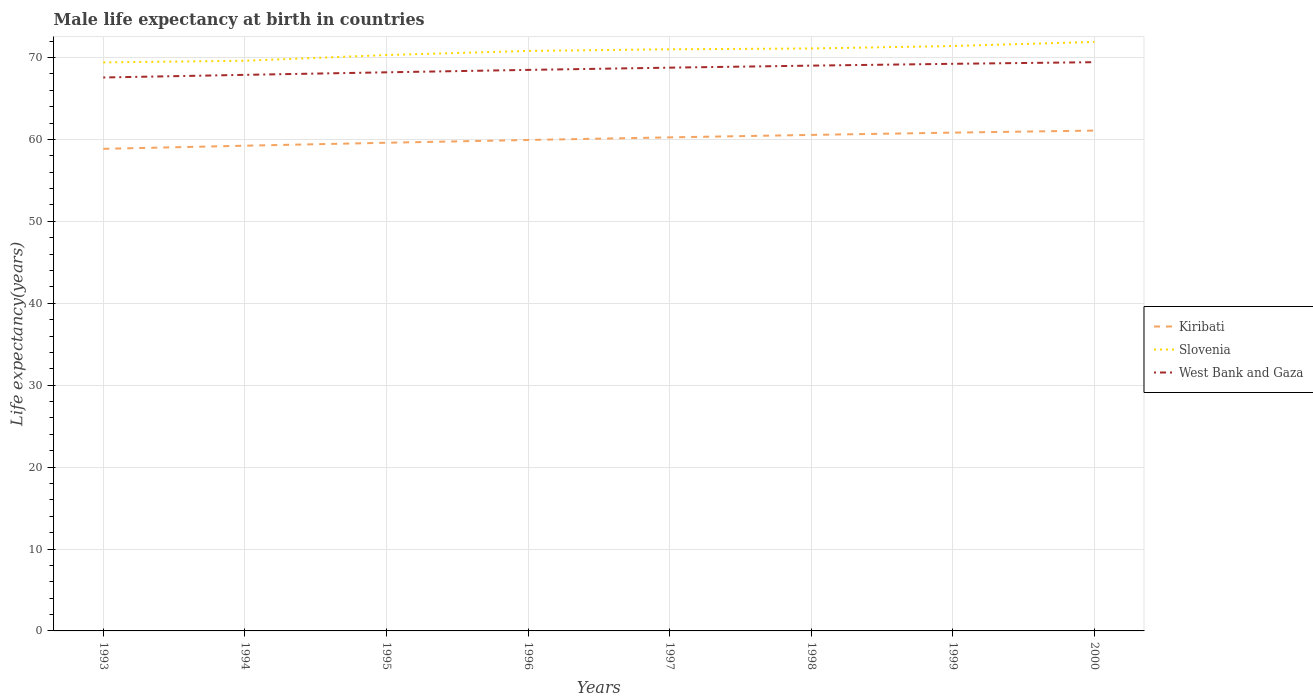Across all years, what is the maximum male life expectancy at birth in Kiribati?
Your answer should be compact. 58.85. What is the total male life expectancy at birth in West Bank and Gaza in the graph?
Ensure brevity in your answer.  -0.94. How many years are there in the graph?
Your answer should be compact. 8. What is the difference between two consecutive major ticks on the Y-axis?
Your answer should be compact. 10. Are the values on the major ticks of Y-axis written in scientific E-notation?
Provide a succinct answer. No. Does the graph contain grids?
Provide a short and direct response. Yes. What is the title of the graph?
Offer a very short reply. Male life expectancy at birth in countries. What is the label or title of the Y-axis?
Provide a short and direct response. Life expectancy(years). What is the Life expectancy(years) in Kiribati in 1993?
Ensure brevity in your answer.  58.85. What is the Life expectancy(years) of Slovenia in 1993?
Your answer should be very brief. 69.4. What is the Life expectancy(years) of West Bank and Gaza in 1993?
Offer a terse response. 67.56. What is the Life expectancy(years) in Kiribati in 1994?
Provide a short and direct response. 59.23. What is the Life expectancy(years) of Slovenia in 1994?
Your response must be concise. 69.6. What is the Life expectancy(years) in West Bank and Gaza in 1994?
Keep it short and to the point. 67.88. What is the Life expectancy(years) in Kiribati in 1995?
Your answer should be very brief. 59.59. What is the Life expectancy(years) in Slovenia in 1995?
Provide a short and direct response. 70.3. What is the Life expectancy(years) of West Bank and Gaza in 1995?
Your answer should be very brief. 68.19. What is the Life expectancy(years) in Kiribati in 1996?
Offer a terse response. 59.93. What is the Life expectancy(years) of Slovenia in 1996?
Offer a very short reply. 70.8. What is the Life expectancy(years) in West Bank and Gaza in 1996?
Offer a very short reply. 68.48. What is the Life expectancy(years) in Kiribati in 1997?
Make the answer very short. 60.25. What is the Life expectancy(years) in Slovenia in 1997?
Offer a very short reply. 71. What is the Life expectancy(years) in West Bank and Gaza in 1997?
Offer a terse response. 68.76. What is the Life expectancy(years) in Kiribati in 1998?
Provide a succinct answer. 60.55. What is the Life expectancy(years) in Slovenia in 1998?
Ensure brevity in your answer.  71.1. What is the Life expectancy(years) in West Bank and Gaza in 1998?
Your answer should be compact. 69.01. What is the Life expectancy(years) in Kiribati in 1999?
Provide a short and direct response. 60.83. What is the Life expectancy(years) in Slovenia in 1999?
Your answer should be compact. 71.4. What is the Life expectancy(years) of West Bank and Gaza in 1999?
Provide a short and direct response. 69.23. What is the Life expectancy(years) of Kiribati in 2000?
Keep it short and to the point. 61.08. What is the Life expectancy(years) in Slovenia in 2000?
Your response must be concise. 71.9. What is the Life expectancy(years) in West Bank and Gaza in 2000?
Provide a succinct answer. 69.43. Across all years, what is the maximum Life expectancy(years) of Kiribati?
Provide a short and direct response. 61.08. Across all years, what is the maximum Life expectancy(years) in Slovenia?
Give a very brief answer. 71.9. Across all years, what is the maximum Life expectancy(years) of West Bank and Gaza?
Your answer should be compact. 69.43. Across all years, what is the minimum Life expectancy(years) of Kiribati?
Offer a very short reply. 58.85. Across all years, what is the minimum Life expectancy(years) of Slovenia?
Ensure brevity in your answer.  69.4. Across all years, what is the minimum Life expectancy(years) in West Bank and Gaza?
Keep it short and to the point. 67.56. What is the total Life expectancy(years) in Kiribati in the graph?
Ensure brevity in your answer.  480.31. What is the total Life expectancy(years) of Slovenia in the graph?
Make the answer very short. 565.5. What is the total Life expectancy(years) of West Bank and Gaza in the graph?
Provide a short and direct response. 548.53. What is the difference between the Life expectancy(years) in Kiribati in 1993 and that in 1994?
Ensure brevity in your answer.  -0.38. What is the difference between the Life expectancy(years) in West Bank and Gaza in 1993 and that in 1994?
Make the answer very short. -0.32. What is the difference between the Life expectancy(years) in Kiribati in 1993 and that in 1995?
Offer a very short reply. -0.74. What is the difference between the Life expectancy(years) in Slovenia in 1993 and that in 1995?
Your answer should be compact. -0.9. What is the difference between the Life expectancy(years) in West Bank and Gaza in 1993 and that in 1995?
Offer a very short reply. -0.63. What is the difference between the Life expectancy(years) of Kiribati in 1993 and that in 1996?
Provide a short and direct response. -1.08. What is the difference between the Life expectancy(years) of West Bank and Gaza in 1993 and that in 1996?
Offer a terse response. -0.93. What is the difference between the Life expectancy(years) of Kiribati in 1993 and that in 1997?
Provide a succinct answer. -1.4. What is the difference between the Life expectancy(years) in West Bank and Gaza in 1993 and that in 1997?
Keep it short and to the point. -1.2. What is the difference between the Life expectancy(years) in Kiribati in 1993 and that in 1998?
Your response must be concise. -1.7. What is the difference between the Life expectancy(years) in Slovenia in 1993 and that in 1998?
Offer a terse response. -1.7. What is the difference between the Life expectancy(years) in West Bank and Gaza in 1993 and that in 1998?
Keep it short and to the point. -1.45. What is the difference between the Life expectancy(years) in Kiribati in 1993 and that in 1999?
Provide a succinct answer. -1.98. What is the difference between the Life expectancy(years) in West Bank and Gaza in 1993 and that in 1999?
Provide a succinct answer. -1.67. What is the difference between the Life expectancy(years) of Kiribati in 1993 and that in 2000?
Provide a succinct answer. -2.23. What is the difference between the Life expectancy(years) in Slovenia in 1993 and that in 2000?
Offer a terse response. -2.5. What is the difference between the Life expectancy(years) of West Bank and Gaza in 1993 and that in 2000?
Offer a very short reply. -1.87. What is the difference between the Life expectancy(years) of Kiribati in 1994 and that in 1995?
Your response must be concise. -0.36. What is the difference between the Life expectancy(years) of Slovenia in 1994 and that in 1995?
Your answer should be very brief. -0.7. What is the difference between the Life expectancy(years) in West Bank and Gaza in 1994 and that in 1995?
Your answer should be very brief. -0.31. What is the difference between the Life expectancy(years) in Kiribati in 1994 and that in 1996?
Provide a succinct answer. -0.7. What is the difference between the Life expectancy(years) in West Bank and Gaza in 1994 and that in 1996?
Keep it short and to the point. -0.6. What is the difference between the Life expectancy(years) in Kiribati in 1994 and that in 1997?
Offer a terse response. -1.02. What is the difference between the Life expectancy(years) of West Bank and Gaza in 1994 and that in 1997?
Give a very brief answer. -0.88. What is the difference between the Life expectancy(years) of Kiribati in 1994 and that in 1998?
Provide a short and direct response. -1.32. What is the difference between the Life expectancy(years) in Slovenia in 1994 and that in 1998?
Make the answer very short. -1.5. What is the difference between the Life expectancy(years) in West Bank and Gaza in 1994 and that in 1998?
Give a very brief answer. -1.13. What is the difference between the Life expectancy(years) in Kiribati in 1994 and that in 1999?
Keep it short and to the point. -1.6. What is the difference between the Life expectancy(years) in Slovenia in 1994 and that in 1999?
Provide a succinct answer. -1.8. What is the difference between the Life expectancy(years) in West Bank and Gaza in 1994 and that in 1999?
Provide a short and direct response. -1.35. What is the difference between the Life expectancy(years) in Kiribati in 1994 and that in 2000?
Your answer should be very brief. -1.85. What is the difference between the Life expectancy(years) of West Bank and Gaza in 1994 and that in 2000?
Your answer should be very brief. -1.55. What is the difference between the Life expectancy(years) in Kiribati in 1995 and that in 1996?
Provide a short and direct response. -0.34. What is the difference between the Life expectancy(years) in West Bank and Gaza in 1995 and that in 1996?
Offer a very short reply. -0.29. What is the difference between the Life expectancy(years) of Kiribati in 1995 and that in 1997?
Your response must be concise. -0.66. What is the difference between the Life expectancy(years) in Slovenia in 1995 and that in 1997?
Your answer should be compact. -0.7. What is the difference between the Life expectancy(years) in West Bank and Gaza in 1995 and that in 1997?
Keep it short and to the point. -0.57. What is the difference between the Life expectancy(years) in Kiribati in 1995 and that in 1998?
Make the answer very short. -0.96. What is the difference between the Life expectancy(years) in Slovenia in 1995 and that in 1998?
Your answer should be very brief. -0.8. What is the difference between the Life expectancy(years) in West Bank and Gaza in 1995 and that in 1998?
Your response must be concise. -0.82. What is the difference between the Life expectancy(years) in Kiribati in 1995 and that in 1999?
Give a very brief answer. -1.24. What is the difference between the Life expectancy(years) in Slovenia in 1995 and that in 1999?
Make the answer very short. -1.1. What is the difference between the Life expectancy(years) of West Bank and Gaza in 1995 and that in 1999?
Provide a short and direct response. -1.04. What is the difference between the Life expectancy(years) in Kiribati in 1995 and that in 2000?
Ensure brevity in your answer.  -1.49. What is the difference between the Life expectancy(years) in West Bank and Gaza in 1995 and that in 2000?
Ensure brevity in your answer.  -1.24. What is the difference between the Life expectancy(years) of Kiribati in 1996 and that in 1997?
Offer a terse response. -0.32. What is the difference between the Life expectancy(years) of West Bank and Gaza in 1996 and that in 1997?
Ensure brevity in your answer.  -0.27. What is the difference between the Life expectancy(years) in Kiribati in 1996 and that in 1998?
Keep it short and to the point. -0.62. What is the difference between the Life expectancy(years) in West Bank and Gaza in 1996 and that in 1998?
Provide a short and direct response. -0.52. What is the difference between the Life expectancy(years) in Kiribati in 1996 and that in 1999?
Ensure brevity in your answer.  -0.9. What is the difference between the Life expectancy(years) of Slovenia in 1996 and that in 1999?
Your response must be concise. -0.6. What is the difference between the Life expectancy(years) of West Bank and Gaza in 1996 and that in 1999?
Provide a succinct answer. -0.74. What is the difference between the Life expectancy(years) in Kiribati in 1996 and that in 2000?
Make the answer very short. -1.15. What is the difference between the Life expectancy(years) in West Bank and Gaza in 1996 and that in 2000?
Keep it short and to the point. -0.94. What is the difference between the Life expectancy(years) in Kiribati in 1997 and that in 1998?
Make the answer very short. -0.3. What is the difference between the Life expectancy(years) of Slovenia in 1997 and that in 1998?
Give a very brief answer. -0.1. What is the difference between the Life expectancy(years) of West Bank and Gaza in 1997 and that in 1998?
Your answer should be compact. -0.25. What is the difference between the Life expectancy(years) of Kiribati in 1997 and that in 1999?
Keep it short and to the point. -0.58. What is the difference between the Life expectancy(years) in West Bank and Gaza in 1997 and that in 1999?
Your answer should be very brief. -0.47. What is the difference between the Life expectancy(years) in Kiribati in 1997 and that in 2000?
Provide a short and direct response. -0.83. What is the difference between the Life expectancy(years) in Slovenia in 1997 and that in 2000?
Keep it short and to the point. -0.9. What is the difference between the Life expectancy(years) in West Bank and Gaza in 1997 and that in 2000?
Offer a very short reply. -0.67. What is the difference between the Life expectancy(years) of Kiribati in 1998 and that in 1999?
Give a very brief answer. -0.28. What is the difference between the Life expectancy(years) in Slovenia in 1998 and that in 1999?
Your response must be concise. -0.3. What is the difference between the Life expectancy(years) in West Bank and Gaza in 1998 and that in 1999?
Your response must be concise. -0.22. What is the difference between the Life expectancy(years) in Kiribati in 1998 and that in 2000?
Make the answer very short. -0.53. What is the difference between the Life expectancy(years) of West Bank and Gaza in 1998 and that in 2000?
Your answer should be very brief. -0.42. What is the difference between the Life expectancy(years) of Kiribati in 1999 and that in 2000?
Provide a short and direct response. -0.25. What is the difference between the Life expectancy(years) in West Bank and Gaza in 1999 and that in 2000?
Your answer should be very brief. -0.2. What is the difference between the Life expectancy(years) in Kiribati in 1993 and the Life expectancy(years) in Slovenia in 1994?
Your response must be concise. -10.75. What is the difference between the Life expectancy(years) of Kiribati in 1993 and the Life expectancy(years) of West Bank and Gaza in 1994?
Offer a very short reply. -9.03. What is the difference between the Life expectancy(years) of Slovenia in 1993 and the Life expectancy(years) of West Bank and Gaza in 1994?
Provide a succinct answer. 1.52. What is the difference between the Life expectancy(years) of Kiribati in 1993 and the Life expectancy(years) of Slovenia in 1995?
Your response must be concise. -11.45. What is the difference between the Life expectancy(years) of Kiribati in 1993 and the Life expectancy(years) of West Bank and Gaza in 1995?
Ensure brevity in your answer.  -9.34. What is the difference between the Life expectancy(years) of Slovenia in 1993 and the Life expectancy(years) of West Bank and Gaza in 1995?
Make the answer very short. 1.21. What is the difference between the Life expectancy(years) of Kiribati in 1993 and the Life expectancy(years) of Slovenia in 1996?
Offer a terse response. -11.95. What is the difference between the Life expectancy(years) in Kiribati in 1993 and the Life expectancy(years) in West Bank and Gaza in 1996?
Keep it short and to the point. -9.64. What is the difference between the Life expectancy(years) of Slovenia in 1993 and the Life expectancy(years) of West Bank and Gaza in 1996?
Your answer should be compact. 0.92. What is the difference between the Life expectancy(years) in Kiribati in 1993 and the Life expectancy(years) in Slovenia in 1997?
Your answer should be compact. -12.15. What is the difference between the Life expectancy(years) of Kiribati in 1993 and the Life expectancy(years) of West Bank and Gaza in 1997?
Provide a short and direct response. -9.91. What is the difference between the Life expectancy(years) in Slovenia in 1993 and the Life expectancy(years) in West Bank and Gaza in 1997?
Your response must be concise. 0.64. What is the difference between the Life expectancy(years) of Kiribati in 1993 and the Life expectancy(years) of Slovenia in 1998?
Make the answer very short. -12.25. What is the difference between the Life expectancy(years) of Kiribati in 1993 and the Life expectancy(years) of West Bank and Gaza in 1998?
Your answer should be very brief. -10.16. What is the difference between the Life expectancy(years) of Slovenia in 1993 and the Life expectancy(years) of West Bank and Gaza in 1998?
Provide a succinct answer. 0.39. What is the difference between the Life expectancy(years) in Kiribati in 1993 and the Life expectancy(years) in Slovenia in 1999?
Your answer should be very brief. -12.55. What is the difference between the Life expectancy(years) in Kiribati in 1993 and the Life expectancy(years) in West Bank and Gaza in 1999?
Provide a short and direct response. -10.38. What is the difference between the Life expectancy(years) of Slovenia in 1993 and the Life expectancy(years) of West Bank and Gaza in 1999?
Your answer should be very brief. 0.17. What is the difference between the Life expectancy(years) in Kiribati in 1993 and the Life expectancy(years) in Slovenia in 2000?
Offer a terse response. -13.05. What is the difference between the Life expectancy(years) in Kiribati in 1993 and the Life expectancy(years) in West Bank and Gaza in 2000?
Your answer should be very brief. -10.58. What is the difference between the Life expectancy(years) in Slovenia in 1993 and the Life expectancy(years) in West Bank and Gaza in 2000?
Your answer should be very brief. -0.03. What is the difference between the Life expectancy(years) of Kiribati in 1994 and the Life expectancy(years) of Slovenia in 1995?
Offer a terse response. -11.07. What is the difference between the Life expectancy(years) in Kiribati in 1994 and the Life expectancy(years) in West Bank and Gaza in 1995?
Provide a short and direct response. -8.96. What is the difference between the Life expectancy(years) of Slovenia in 1994 and the Life expectancy(years) of West Bank and Gaza in 1995?
Ensure brevity in your answer.  1.41. What is the difference between the Life expectancy(years) in Kiribati in 1994 and the Life expectancy(years) in Slovenia in 1996?
Keep it short and to the point. -11.57. What is the difference between the Life expectancy(years) in Kiribati in 1994 and the Life expectancy(years) in West Bank and Gaza in 1996?
Offer a terse response. -9.25. What is the difference between the Life expectancy(years) of Slovenia in 1994 and the Life expectancy(years) of West Bank and Gaza in 1996?
Your response must be concise. 1.11. What is the difference between the Life expectancy(years) in Kiribati in 1994 and the Life expectancy(years) in Slovenia in 1997?
Provide a short and direct response. -11.77. What is the difference between the Life expectancy(years) of Kiribati in 1994 and the Life expectancy(years) of West Bank and Gaza in 1997?
Make the answer very short. -9.53. What is the difference between the Life expectancy(years) in Slovenia in 1994 and the Life expectancy(years) in West Bank and Gaza in 1997?
Your answer should be compact. 0.84. What is the difference between the Life expectancy(years) of Kiribati in 1994 and the Life expectancy(years) of Slovenia in 1998?
Provide a succinct answer. -11.87. What is the difference between the Life expectancy(years) in Kiribati in 1994 and the Life expectancy(years) in West Bank and Gaza in 1998?
Your response must be concise. -9.78. What is the difference between the Life expectancy(years) in Slovenia in 1994 and the Life expectancy(years) in West Bank and Gaza in 1998?
Keep it short and to the point. 0.59. What is the difference between the Life expectancy(years) in Kiribati in 1994 and the Life expectancy(years) in Slovenia in 1999?
Make the answer very short. -12.17. What is the difference between the Life expectancy(years) of Kiribati in 1994 and the Life expectancy(years) of West Bank and Gaza in 1999?
Offer a terse response. -10. What is the difference between the Life expectancy(years) in Slovenia in 1994 and the Life expectancy(years) in West Bank and Gaza in 1999?
Provide a short and direct response. 0.37. What is the difference between the Life expectancy(years) of Kiribati in 1994 and the Life expectancy(years) of Slovenia in 2000?
Provide a short and direct response. -12.67. What is the difference between the Life expectancy(years) in Kiribati in 1994 and the Life expectancy(years) in West Bank and Gaza in 2000?
Your answer should be compact. -10.2. What is the difference between the Life expectancy(years) in Slovenia in 1994 and the Life expectancy(years) in West Bank and Gaza in 2000?
Keep it short and to the point. 0.17. What is the difference between the Life expectancy(years) in Kiribati in 1995 and the Life expectancy(years) in Slovenia in 1996?
Ensure brevity in your answer.  -11.21. What is the difference between the Life expectancy(years) of Kiribati in 1995 and the Life expectancy(years) of West Bank and Gaza in 1996?
Your answer should be very brief. -8.89. What is the difference between the Life expectancy(years) in Slovenia in 1995 and the Life expectancy(years) in West Bank and Gaza in 1996?
Make the answer very short. 1.81. What is the difference between the Life expectancy(years) of Kiribati in 1995 and the Life expectancy(years) of Slovenia in 1997?
Ensure brevity in your answer.  -11.41. What is the difference between the Life expectancy(years) in Kiribati in 1995 and the Life expectancy(years) in West Bank and Gaza in 1997?
Give a very brief answer. -9.17. What is the difference between the Life expectancy(years) in Slovenia in 1995 and the Life expectancy(years) in West Bank and Gaza in 1997?
Offer a very short reply. 1.54. What is the difference between the Life expectancy(years) in Kiribati in 1995 and the Life expectancy(years) in Slovenia in 1998?
Make the answer very short. -11.51. What is the difference between the Life expectancy(years) in Kiribati in 1995 and the Life expectancy(years) in West Bank and Gaza in 1998?
Offer a very short reply. -9.41. What is the difference between the Life expectancy(years) in Slovenia in 1995 and the Life expectancy(years) in West Bank and Gaza in 1998?
Give a very brief answer. 1.29. What is the difference between the Life expectancy(years) in Kiribati in 1995 and the Life expectancy(years) in Slovenia in 1999?
Provide a succinct answer. -11.81. What is the difference between the Life expectancy(years) in Kiribati in 1995 and the Life expectancy(years) in West Bank and Gaza in 1999?
Give a very brief answer. -9.64. What is the difference between the Life expectancy(years) in Slovenia in 1995 and the Life expectancy(years) in West Bank and Gaza in 1999?
Your answer should be compact. 1.07. What is the difference between the Life expectancy(years) in Kiribati in 1995 and the Life expectancy(years) in Slovenia in 2000?
Your response must be concise. -12.31. What is the difference between the Life expectancy(years) of Kiribati in 1995 and the Life expectancy(years) of West Bank and Gaza in 2000?
Provide a short and direct response. -9.83. What is the difference between the Life expectancy(years) in Slovenia in 1995 and the Life expectancy(years) in West Bank and Gaza in 2000?
Your response must be concise. 0.87. What is the difference between the Life expectancy(years) in Kiribati in 1996 and the Life expectancy(years) in Slovenia in 1997?
Offer a terse response. -11.07. What is the difference between the Life expectancy(years) of Kiribati in 1996 and the Life expectancy(years) of West Bank and Gaza in 1997?
Keep it short and to the point. -8.83. What is the difference between the Life expectancy(years) of Slovenia in 1996 and the Life expectancy(years) of West Bank and Gaza in 1997?
Offer a very short reply. 2.04. What is the difference between the Life expectancy(years) of Kiribati in 1996 and the Life expectancy(years) of Slovenia in 1998?
Provide a short and direct response. -11.17. What is the difference between the Life expectancy(years) of Kiribati in 1996 and the Life expectancy(years) of West Bank and Gaza in 1998?
Your answer should be compact. -9.08. What is the difference between the Life expectancy(years) of Slovenia in 1996 and the Life expectancy(years) of West Bank and Gaza in 1998?
Your response must be concise. 1.79. What is the difference between the Life expectancy(years) of Kiribati in 1996 and the Life expectancy(years) of Slovenia in 1999?
Keep it short and to the point. -11.47. What is the difference between the Life expectancy(years) in Kiribati in 1996 and the Life expectancy(years) in West Bank and Gaza in 1999?
Your answer should be very brief. -9.3. What is the difference between the Life expectancy(years) of Slovenia in 1996 and the Life expectancy(years) of West Bank and Gaza in 1999?
Give a very brief answer. 1.57. What is the difference between the Life expectancy(years) in Kiribati in 1996 and the Life expectancy(years) in Slovenia in 2000?
Offer a terse response. -11.97. What is the difference between the Life expectancy(years) in Kiribati in 1996 and the Life expectancy(years) in West Bank and Gaza in 2000?
Your response must be concise. -9.5. What is the difference between the Life expectancy(years) in Slovenia in 1996 and the Life expectancy(years) in West Bank and Gaza in 2000?
Make the answer very short. 1.37. What is the difference between the Life expectancy(years) in Kiribati in 1997 and the Life expectancy(years) in Slovenia in 1998?
Provide a short and direct response. -10.85. What is the difference between the Life expectancy(years) of Kiribati in 1997 and the Life expectancy(years) of West Bank and Gaza in 1998?
Provide a short and direct response. -8.76. What is the difference between the Life expectancy(years) of Slovenia in 1997 and the Life expectancy(years) of West Bank and Gaza in 1998?
Provide a succinct answer. 1.99. What is the difference between the Life expectancy(years) of Kiribati in 1997 and the Life expectancy(years) of Slovenia in 1999?
Keep it short and to the point. -11.15. What is the difference between the Life expectancy(years) of Kiribati in 1997 and the Life expectancy(years) of West Bank and Gaza in 1999?
Offer a very short reply. -8.98. What is the difference between the Life expectancy(years) in Slovenia in 1997 and the Life expectancy(years) in West Bank and Gaza in 1999?
Provide a short and direct response. 1.77. What is the difference between the Life expectancy(years) of Kiribati in 1997 and the Life expectancy(years) of Slovenia in 2000?
Your answer should be compact. -11.65. What is the difference between the Life expectancy(years) in Kiribati in 1997 and the Life expectancy(years) in West Bank and Gaza in 2000?
Keep it short and to the point. -9.18. What is the difference between the Life expectancy(years) of Slovenia in 1997 and the Life expectancy(years) of West Bank and Gaza in 2000?
Your response must be concise. 1.57. What is the difference between the Life expectancy(years) in Kiribati in 1998 and the Life expectancy(years) in Slovenia in 1999?
Your response must be concise. -10.85. What is the difference between the Life expectancy(years) of Kiribati in 1998 and the Life expectancy(years) of West Bank and Gaza in 1999?
Offer a very short reply. -8.68. What is the difference between the Life expectancy(years) in Slovenia in 1998 and the Life expectancy(years) in West Bank and Gaza in 1999?
Your response must be concise. 1.87. What is the difference between the Life expectancy(years) of Kiribati in 1998 and the Life expectancy(years) of Slovenia in 2000?
Ensure brevity in your answer.  -11.35. What is the difference between the Life expectancy(years) in Kiribati in 1998 and the Life expectancy(years) in West Bank and Gaza in 2000?
Keep it short and to the point. -8.88. What is the difference between the Life expectancy(years) of Slovenia in 1998 and the Life expectancy(years) of West Bank and Gaza in 2000?
Your answer should be compact. 1.67. What is the difference between the Life expectancy(years) of Kiribati in 1999 and the Life expectancy(years) of Slovenia in 2000?
Make the answer very short. -11.07. What is the difference between the Life expectancy(years) in Kiribati in 1999 and the Life expectancy(years) in West Bank and Gaza in 2000?
Offer a very short reply. -8.6. What is the difference between the Life expectancy(years) of Slovenia in 1999 and the Life expectancy(years) of West Bank and Gaza in 2000?
Offer a very short reply. 1.97. What is the average Life expectancy(years) of Kiribati per year?
Provide a succinct answer. 60.04. What is the average Life expectancy(years) of Slovenia per year?
Your response must be concise. 70.69. What is the average Life expectancy(years) of West Bank and Gaza per year?
Your answer should be very brief. 68.57. In the year 1993, what is the difference between the Life expectancy(years) in Kiribati and Life expectancy(years) in Slovenia?
Give a very brief answer. -10.55. In the year 1993, what is the difference between the Life expectancy(years) of Kiribati and Life expectancy(years) of West Bank and Gaza?
Your answer should be compact. -8.71. In the year 1993, what is the difference between the Life expectancy(years) in Slovenia and Life expectancy(years) in West Bank and Gaza?
Offer a very short reply. 1.84. In the year 1994, what is the difference between the Life expectancy(years) in Kiribati and Life expectancy(years) in Slovenia?
Give a very brief answer. -10.37. In the year 1994, what is the difference between the Life expectancy(years) in Kiribati and Life expectancy(years) in West Bank and Gaza?
Make the answer very short. -8.65. In the year 1994, what is the difference between the Life expectancy(years) in Slovenia and Life expectancy(years) in West Bank and Gaza?
Your answer should be very brief. 1.72. In the year 1995, what is the difference between the Life expectancy(years) of Kiribati and Life expectancy(years) of Slovenia?
Keep it short and to the point. -10.71. In the year 1995, what is the difference between the Life expectancy(years) of Kiribati and Life expectancy(years) of West Bank and Gaza?
Offer a very short reply. -8.6. In the year 1995, what is the difference between the Life expectancy(years) of Slovenia and Life expectancy(years) of West Bank and Gaza?
Keep it short and to the point. 2.11. In the year 1996, what is the difference between the Life expectancy(years) of Kiribati and Life expectancy(years) of Slovenia?
Offer a terse response. -10.87. In the year 1996, what is the difference between the Life expectancy(years) in Kiribati and Life expectancy(years) in West Bank and Gaza?
Ensure brevity in your answer.  -8.55. In the year 1996, what is the difference between the Life expectancy(years) in Slovenia and Life expectancy(years) in West Bank and Gaza?
Give a very brief answer. 2.31. In the year 1997, what is the difference between the Life expectancy(years) of Kiribati and Life expectancy(years) of Slovenia?
Offer a terse response. -10.75. In the year 1997, what is the difference between the Life expectancy(years) in Kiribati and Life expectancy(years) in West Bank and Gaza?
Provide a short and direct response. -8.51. In the year 1997, what is the difference between the Life expectancy(years) in Slovenia and Life expectancy(years) in West Bank and Gaza?
Ensure brevity in your answer.  2.24. In the year 1998, what is the difference between the Life expectancy(years) in Kiribati and Life expectancy(years) in Slovenia?
Your answer should be compact. -10.55. In the year 1998, what is the difference between the Life expectancy(years) of Kiribati and Life expectancy(years) of West Bank and Gaza?
Give a very brief answer. -8.46. In the year 1998, what is the difference between the Life expectancy(years) of Slovenia and Life expectancy(years) of West Bank and Gaza?
Offer a terse response. 2.09. In the year 1999, what is the difference between the Life expectancy(years) in Kiribati and Life expectancy(years) in Slovenia?
Make the answer very short. -10.57. In the year 1999, what is the difference between the Life expectancy(years) in Kiribati and Life expectancy(years) in West Bank and Gaza?
Your answer should be very brief. -8.4. In the year 1999, what is the difference between the Life expectancy(years) of Slovenia and Life expectancy(years) of West Bank and Gaza?
Give a very brief answer. 2.17. In the year 2000, what is the difference between the Life expectancy(years) of Kiribati and Life expectancy(years) of Slovenia?
Make the answer very short. -10.82. In the year 2000, what is the difference between the Life expectancy(years) of Kiribati and Life expectancy(years) of West Bank and Gaza?
Ensure brevity in your answer.  -8.35. In the year 2000, what is the difference between the Life expectancy(years) in Slovenia and Life expectancy(years) in West Bank and Gaza?
Keep it short and to the point. 2.47. What is the ratio of the Life expectancy(years) in Kiribati in 1993 to that in 1995?
Your answer should be compact. 0.99. What is the ratio of the Life expectancy(years) in Slovenia in 1993 to that in 1995?
Keep it short and to the point. 0.99. What is the ratio of the Life expectancy(years) in West Bank and Gaza in 1993 to that in 1995?
Provide a succinct answer. 0.99. What is the ratio of the Life expectancy(years) of Slovenia in 1993 to that in 1996?
Offer a very short reply. 0.98. What is the ratio of the Life expectancy(years) of West Bank and Gaza in 1993 to that in 1996?
Give a very brief answer. 0.99. What is the ratio of the Life expectancy(years) of Kiribati in 1993 to that in 1997?
Your answer should be very brief. 0.98. What is the ratio of the Life expectancy(years) in Slovenia in 1993 to that in 1997?
Provide a succinct answer. 0.98. What is the ratio of the Life expectancy(years) in West Bank and Gaza in 1993 to that in 1997?
Make the answer very short. 0.98. What is the ratio of the Life expectancy(years) of Kiribati in 1993 to that in 1998?
Provide a short and direct response. 0.97. What is the ratio of the Life expectancy(years) in Slovenia in 1993 to that in 1998?
Make the answer very short. 0.98. What is the ratio of the Life expectancy(years) of Kiribati in 1993 to that in 1999?
Provide a succinct answer. 0.97. What is the ratio of the Life expectancy(years) in West Bank and Gaza in 1993 to that in 1999?
Ensure brevity in your answer.  0.98. What is the ratio of the Life expectancy(years) in Kiribati in 1993 to that in 2000?
Make the answer very short. 0.96. What is the ratio of the Life expectancy(years) of Slovenia in 1993 to that in 2000?
Provide a succinct answer. 0.97. What is the ratio of the Life expectancy(years) in West Bank and Gaza in 1993 to that in 2000?
Your response must be concise. 0.97. What is the ratio of the Life expectancy(years) of Slovenia in 1994 to that in 1995?
Ensure brevity in your answer.  0.99. What is the ratio of the Life expectancy(years) of West Bank and Gaza in 1994 to that in 1995?
Offer a terse response. 1. What is the ratio of the Life expectancy(years) of Kiribati in 1994 to that in 1996?
Your response must be concise. 0.99. What is the ratio of the Life expectancy(years) of Slovenia in 1994 to that in 1996?
Provide a short and direct response. 0.98. What is the ratio of the Life expectancy(years) in West Bank and Gaza in 1994 to that in 1996?
Make the answer very short. 0.99. What is the ratio of the Life expectancy(years) of Kiribati in 1994 to that in 1997?
Offer a terse response. 0.98. What is the ratio of the Life expectancy(years) of Slovenia in 1994 to that in 1997?
Your answer should be very brief. 0.98. What is the ratio of the Life expectancy(years) of West Bank and Gaza in 1994 to that in 1997?
Your response must be concise. 0.99. What is the ratio of the Life expectancy(years) of Kiribati in 1994 to that in 1998?
Provide a succinct answer. 0.98. What is the ratio of the Life expectancy(years) in Slovenia in 1994 to that in 1998?
Provide a short and direct response. 0.98. What is the ratio of the Life expectancy(years) of West Bank and Gaza in 1994 to that in 1998?
Ensure brevity in your answer.  0.98. What is the ratio of the Life expectancy(years) of Kiribati in 1994 to that in 1999?
Your answer should be very brief. 0.97. What is the ratio of the Life expectancy(years) in Slovenia in 1994 to that in 1999?
Offer a very short reply. 0.97. What is the ratio of the Life expectancy(years) in West Bank and Gaza in 1994 to that in 1999?
Offer a very short reply. 0.98. What is the ratio of the Life expectancy(years) of Kiribati in 1994 to that in 2000?
Make the answer very short. 0.97. What is the ratio of the Life expectancy(years) of Slovenia in 1994 to that in 2000?
Provide a succinct answer. 0.97. What is the ratio of the Life expectancy(years) of West Bank and Gaza in 1994 to that in 2000?
Offer a terse response. 0.98. What is the ratio of the Life expectancy(years) in Kiribati in 1995 to that in 1996?
Provide a short and direct response. 0.99. What is the ratio of the Life expectancy(years) of Slovenia in 1995 to that in 1996?
Make the answer very short. 0.99. What is the ratio of the Life expectancy(years) in West Bank and Gaza in 1995 to that in 1996?
Keep it short and to the point. 1. What is the ratio of the Life expectancy(years) of Slovenia in 1995 to that in 1997?
Provide a succinct answer. 0.99. What is the ratio of the Life expectancy(years) in Kiribati in 1995 to that in 1998?
Provide a short and direct response. 0.98. What is the ratio of the Life expectancy(years) of Slovenia in 1995 to that in 1998?
Provide a short and direct response. 0.99. What is the ratio of the Life expectancy(years) of Kiribati in 1995 to that in 1999?
Keep it short and to the point. 0.98. What is the ratio of the Life expectancy(years) in Slovenia in 1995 to that in 1999?
Provide a succinct answer. 0.98. What is the ratio of the Life expectancy(years) in West Bank and Gaza in 1995 to that in 1999?
Offer a terse response. 0.98. What is the ratio of the Life expectancy(years) in Kiribati in 1995 to that in 2000?
Make the answer very short. 0.98. What is the ratio of the Life expectancy(years) of Slovenia in 1995 to that in 2000?
Provide a short and direct response. 0.98. What is the ratio of the Life expectancy(years) in West Bank and Gaza in 1995 to that in 2000?
Keep it short and to the point. 0.98. What is the ratio of the Life expectancy(years) of Kiribati in 1996 to that in 1997?
Make the answer very short. 0.99. What is the ratio of the Life expectancy(years) of West Bank and Gaza in 1996 to that in 1997?
Keep it short and to the point. 1. What is the ratio of the Life expectancy(years) of Kiribati in 1996 to that in 1998?
Your response must be concise. 0.99. What is the ratio of the Life expectancy(years) of Slovenia in 1996 to that in 1998?
Offer a terse response. 1. What is the ratio of the Life expectancy(years) in Slovenia in 1996 to that in 1999?
Give a very brief answer. 0.99. What is the ratio of the Life expectancy(years) in West Bank and Gaza in 1996 to that in 1999?
Your answer should be compact. 0.99. What is the ratio of the Life expectancy(years) of Kiribati in 1996 to that in 2000?
Your answer should be very brief. 0.98. What is the ratio of the Life expectancy(years) of Slovenia in 1996 to that in 2000?
Offer a terse response. 0.98. What is the ratio of the Life expectancy(years) in West Bank and Gaza in 1996 to that in 2000?
Your answer should be compact. 0.99. What is the ratio of the Life expectancy(years) of Slovenia in 1997 to that in 1998?
Keep it short and to the point. 1. What is the ratio of the Life expectancy(years) of Kiribati in 1997 to that in 1999?
Make the answer very short. 0.99. What is the ratio of the Life expectancy(years) of Kiribati in 1997 to that in 2000?
Offer a very short reply. 0.99. What is the ratio of the Life expectancy(years) in Slovenia in 1997 to that in 2000?
Your response must be concise. 0.99. What is the ratio of the Life expectancy(years) in West Bank and Gaza in 1997 to that in 2000?
Keep it short and to the point. 0.99. What is the ratio of the Life expectancy(years) in Kiribati in 1998 to that in 1999?
Your answer should be very brief. 1. What is the ratio of the Life expectancy(years) in Slovenia in 1998 to that in 2000?
Give a very brief answer. 0.99. What is the ratio of the Life expectancy(years) in West Bank and Gaza in 1998 to that in 2000?
Your answer should be compact. 0.99. What is the ratio of the Life expectancy(years) in Kiribati in 1999 to that in 2000?
Ensure brevity in your answer.  1. What is the ratio of the Life expectancy(years) of West Bank and Gaza in 1999 to that in 2000?
Make the answer very short. 1. What is the difference between the highest and the second highest Life expectancy(years) of Kiribati?
Your answer should be compact. 0.25. What is the difference between the highest and the second highest Life expectancy(years) in West Bank and Gaza?
Your response must be concise. 0.2. What is the difference between the highest and the lowest Life expectancy(years) in Kiribati?
Ensure brevity in your answer.  2.23. What is the difference between the highest and the lowest Life expectancy(years) of West Bank and Gaza?
Ensure brevity in your answer.  1.87. 